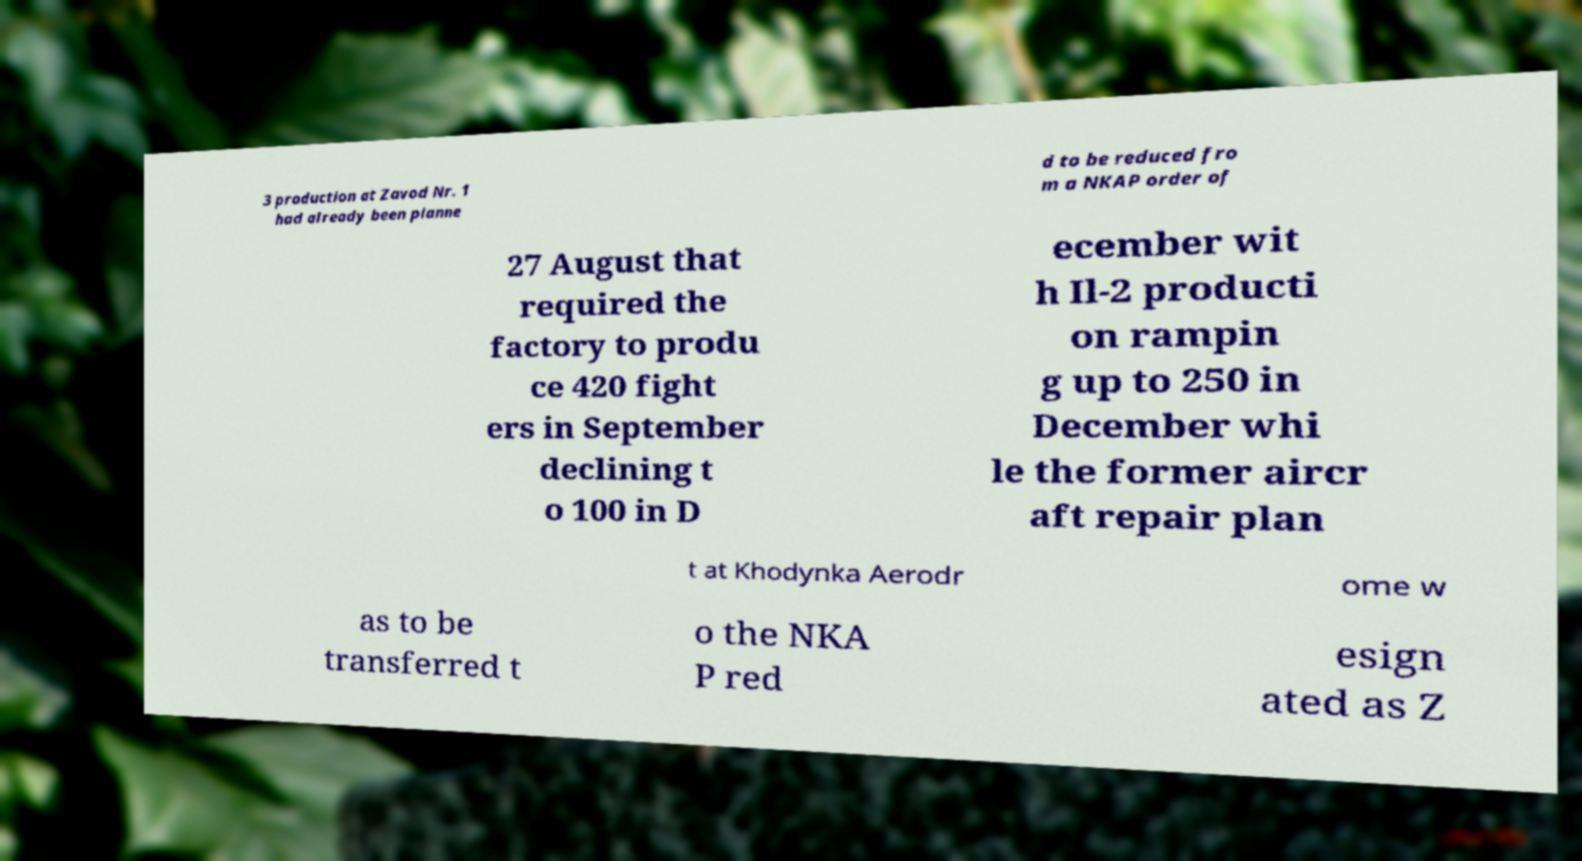I need the written content from this picture converted into text. Can you do that? 3 production at Zavod Nr. 1 had already been planne d to be reduced fro m a NKAP order of 27 August that required the factory to produ ce 420 fight ers in September declining t o 100 in D ecember wit h Il-2 producti on rampin g up to 250 in December whi le the former aircr aft repair plan t at Khodynka Aerodr ome w as to be transferred t o the NKA P red esign ated as Z 